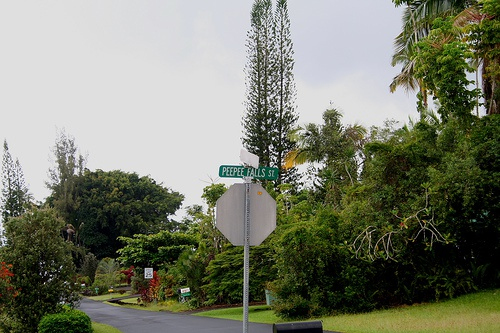Describe the objects in this image and their specific colors. I can see a stop sign in lightgray and gray tones in this image. 